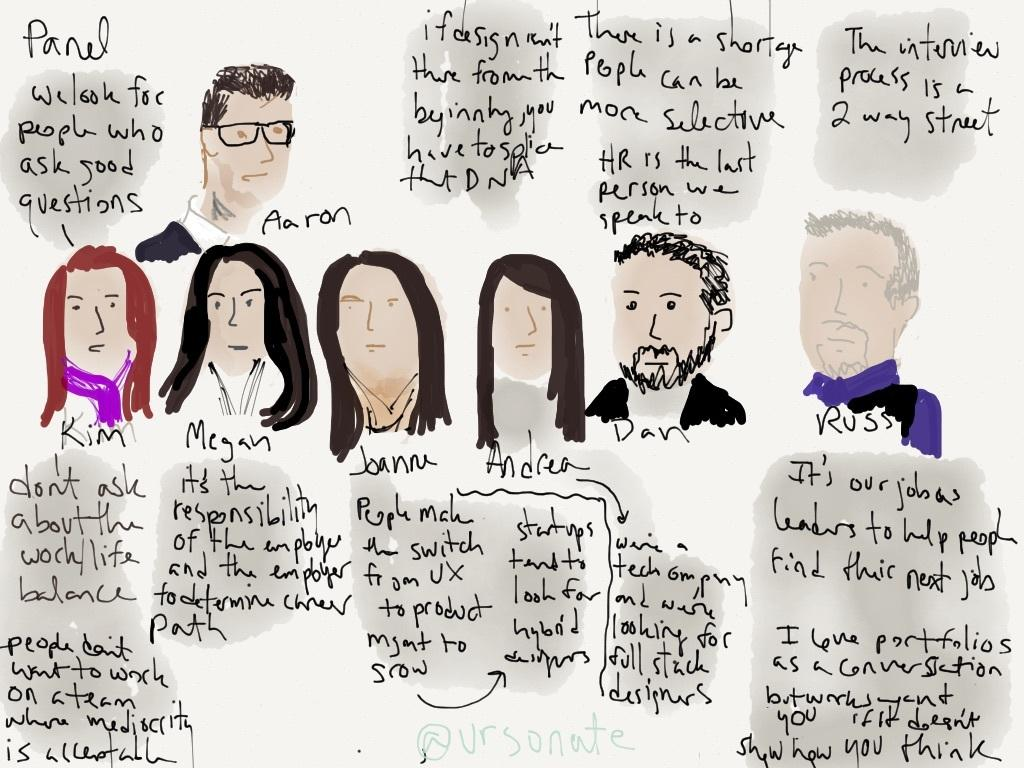What is depicted on the paper in the image? There is a sketch of a few people in the image. Are there any words or letters on the paper? Yes, there is text on the paper in the image. What type of bird is flying over the people in the image? There is no bird present in the image; it only features a sketch of a few people and text on the paper. 